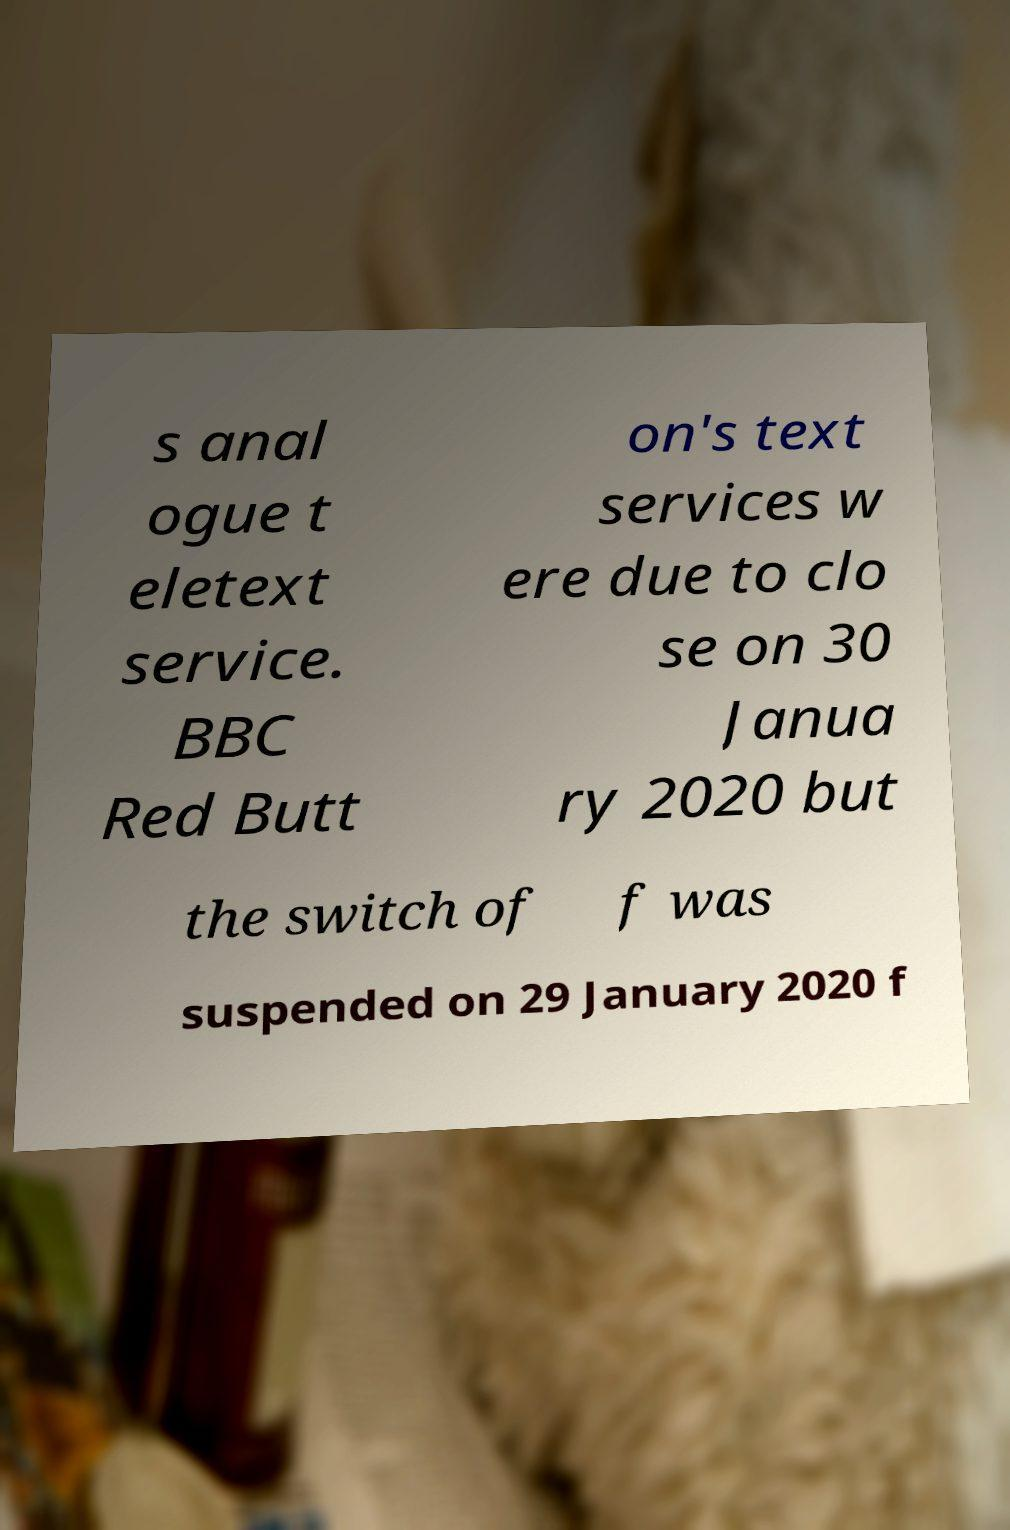For documentation purposes, I need the text within this image transcribed. Could you provide that? s anal ogue t eletext service. BBC Red Butt on's text services w ere due to clo se on 30 Janua ry 2020 but the switch of f was suspended on 29 January 2020 f 